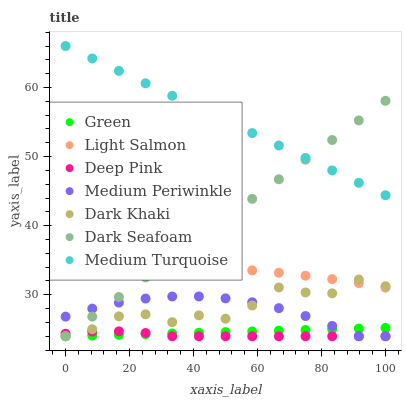Does Deep Pink have the minimum area under the curve?
Answer yes or no. Yes. Does Medium Turquoise have the maximum area under the curve?
Answer yes or no. Yes. Does Medium Periwinkle have the minimum area under the curve?
Answer yes or no. No. Does Medium Periwinkle have the maximum area under the curve?
Answer yes or no. No. Is Green the smoothest?
Answer yes or no. Yes. Is Dark Khaki the roughest?
Answer yes or no. Yes. Is Deep Pink the smoothest?
Answer yes or no. No. Is Deep Pink the roughest?
Answer yes or no. No. Does Deep Pink have the lowest value?
Answer yes or no. Yes. Does Medium Turquoise have the lowest value?
Answer yes or no. No. Does Medium Turquoise have the highest value?
Answer yes or no. Yes. Does Medium Periwinkle have the highest value?
Answer yes or no. No. Is Light Salmon less than Medium Turquoise?
Answer yes or no. Yes. Is Medium Turquoise greater than Medium Periwinkle?
Answer yes or no. Yes. Does Medium Periwinkle intersect Green?
Answer yes or no. Yes. Is Medium Periwinkle less than Green?
Answer yes or no. No. Is Medium Periwinkle greater than Green?
Answer yes or no. No. Does Light Salmon intersect Medium Turquoise?
Answer yes or no. No. 